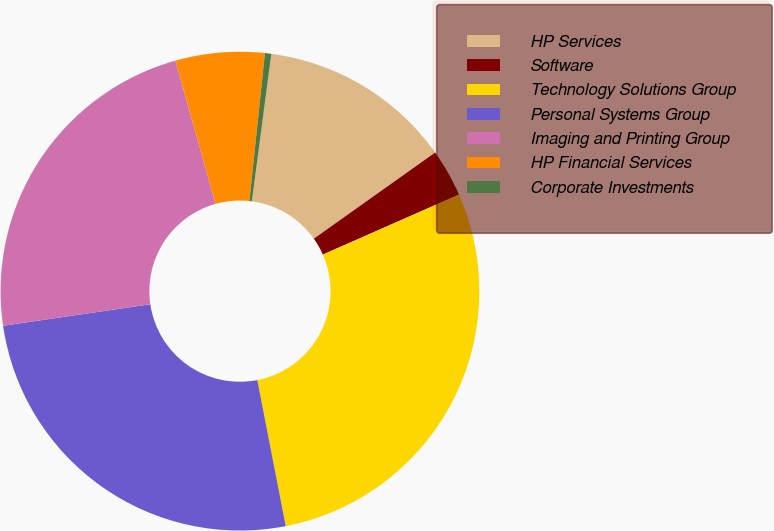<chart> <loc_0><loc_0><loc_500><loc_500><pie_chart><fcel>HP Services<fcel>Software<fcel>Technology Solutions Group<fcel>Personal Systems Group<fcel>Imaging and Printing Group<fcel>HP Financial Services<fcel>Corporate Investments<nl><fcel>13.08%<fcel>3.22%<fcel>28.55%<fcel>25.76%<fcel>22.97%<fcel>6.01%<fcel>0.43%<nl></chart> 